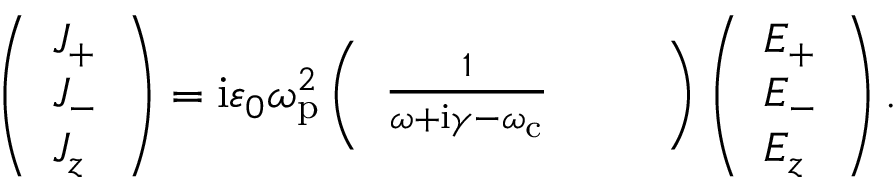Convert formula to latex. <formula><loc_0><loc_0><loc_500><loc_500>\left ( \begin{array} { l } { J _ { + } } \\ { J _ { - } } \\ { J _ { z } } \end{array} \right ) = i \varepsilon _ { 0 } \omega _ { p } ^ { 2 } \left ( \begin{array} { l l l } { \frac { 1 } { \omega + i \gamma - \omega _ { c } } } \end{array} \right ) \left ( \begin{array} { l } { E _ { + } } \\ { E _ { - } } \\ { E _ { z } } \end{array} \right ) .</formula> 